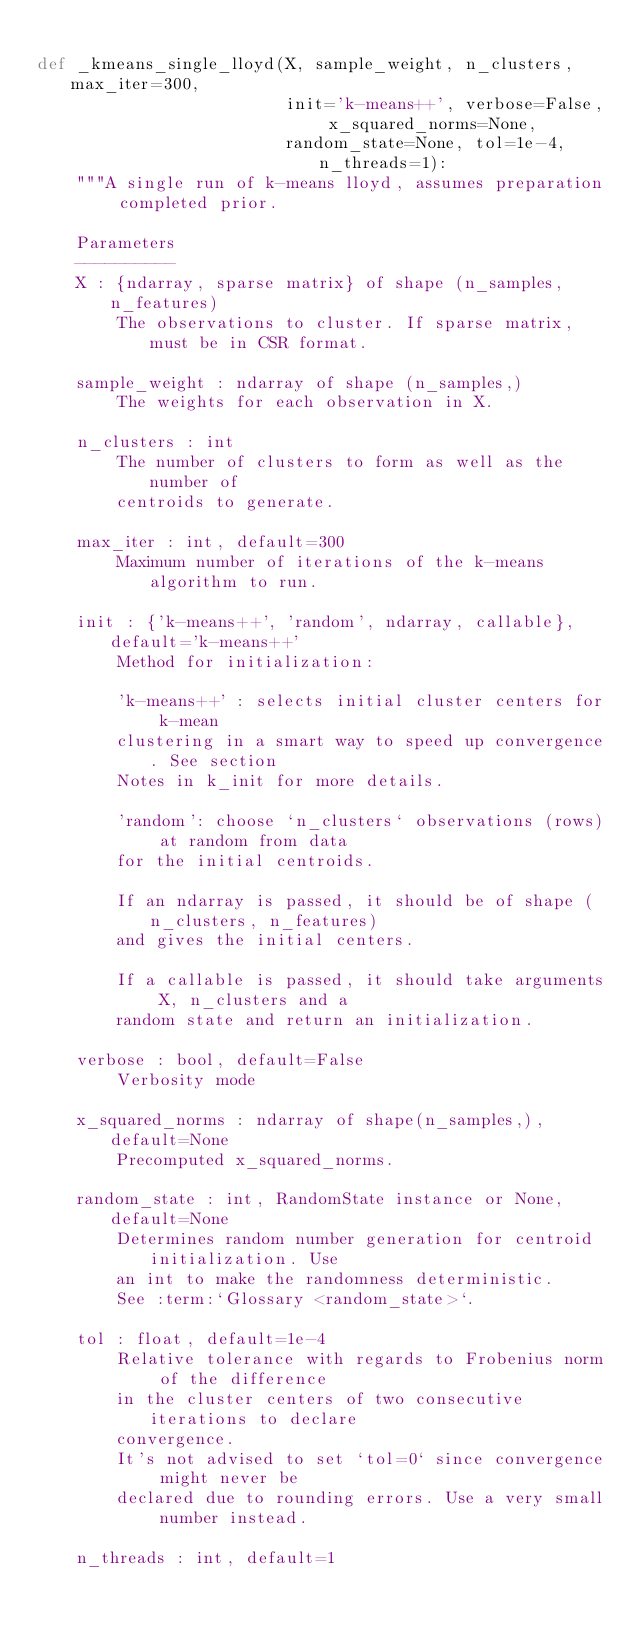Convert code to text. <code><loc_0><loc_0><loc_500><loc_500><_Python_>
def _kmeans_single_lloyd(X, sample_weight, n_clusters, max_iter=300,
                         init='k-means++', verbose=False, x_squared_norms=None,
                         random_state=None, tol=1e-4, n_threads=1):
    """A single run of k-means lloyd, assumes preparation completed prior.

    Parameters
    ----------
    X : {ndarray, sparse matrix} of shape (n_samples, n_features)
        The observations to cluster. If sparse matrix, must be in CSR format.

    sample_weight : ndarray of shape (n_samples,)
        The weights for each observation in X.

    n_clusters : int
        The number of clusters to form as well as the number of
        centroids to generate.

    max_iter : int, default=300
        Maximum number of iterations of the k-means algorithm to run.

    init : {'k-means++', 'random', ndarray, callable}, default='k-means++'
        Method for initialization:

        'k-means++' : selects initial cluster centers for k-mean
        clustering in a smart way to speed up convergence. See section
        Notes in k_init for more details.

        'random': choose `n_clusters` observations (rows) at random from data
        for the initial centroids.

        If an ndarray is passed, it should be of shape (n_clusters, n_features)
        and gives the initial centers.

        If a callable is passed, it should take arguments X, n_clusters and a
        random state and return an initialization.

    verbose : bool, default=False
        Verbosity mode

    x_squared_norms : ndarray of shape(n_samples,), default=None
        Precomputed x_squared_norms.

    random_state : int, RandomState instance or None, default=None
        Determines random number generation for centroid initialization. Use
        an int to make the randomness deterministic.
        See :term:`Glossary <random_state>`.

    tol : float, default=1e-4
        Relative tolerance with regards to Frobenius norm of the difference
        in the cluster centers of two consecutive iterations to declare
        convergence.
        It's not advised to set `tol=0` since convergence might never be
        declared due to rounding errors. Use a very small number instead.

    n_threads : int, default=1</code> 